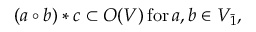<formula> <loc_0><loc_0><loc_500><loc_500>( a \circ b ) * c \subset O ( V ) \, f o r \, a , b \in V _ { \bar { 1 } } ,</formula> 